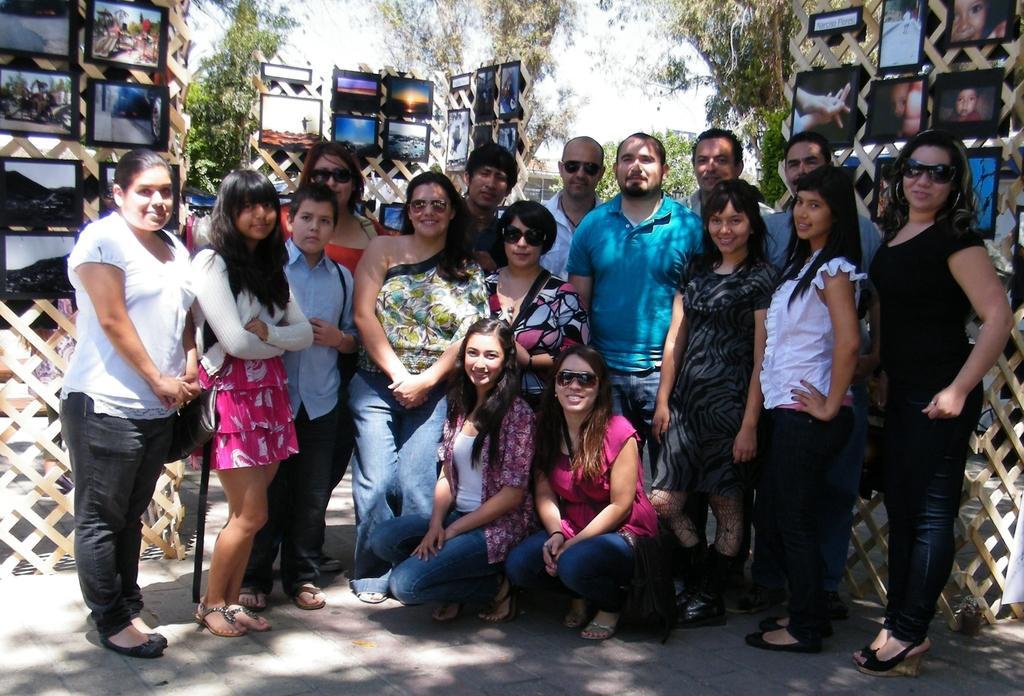Describe this image in one or two sentences. In this picture we can see some people are standing and taking picture, back side we can see so many photo frames are placed. 